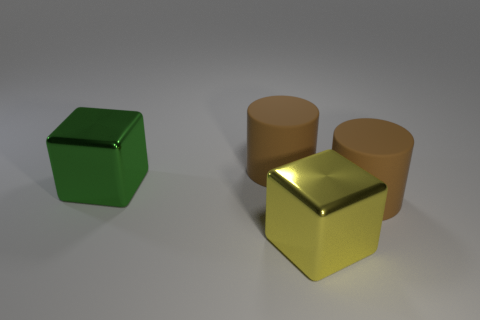Add 1 big brown cylinders. How many objects exist? 5 Subtract 0 cyan spheres. How many objects are left? 4 Subtract all yellow cubes. Subtract all big green metal balls. How many objects are left? 3 Add 2 cubes. How many cubes are left? 4 Add 3 large brown cylinders. How many large brown cylinders exist? 5 